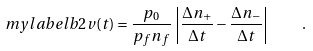<formula> <loc_0><loc_0><loc_500><loc_500>\ m y l a b e l { b 2 } v ( t ) = \frac { p _ { 0 } } { p _ { f } n _ { f } } \, \left | \frac { \Delta n _ { + } } { \Delta t } - \frac { \Delta n _ { - } } { \Delta t } \right | \quad .</formula> 